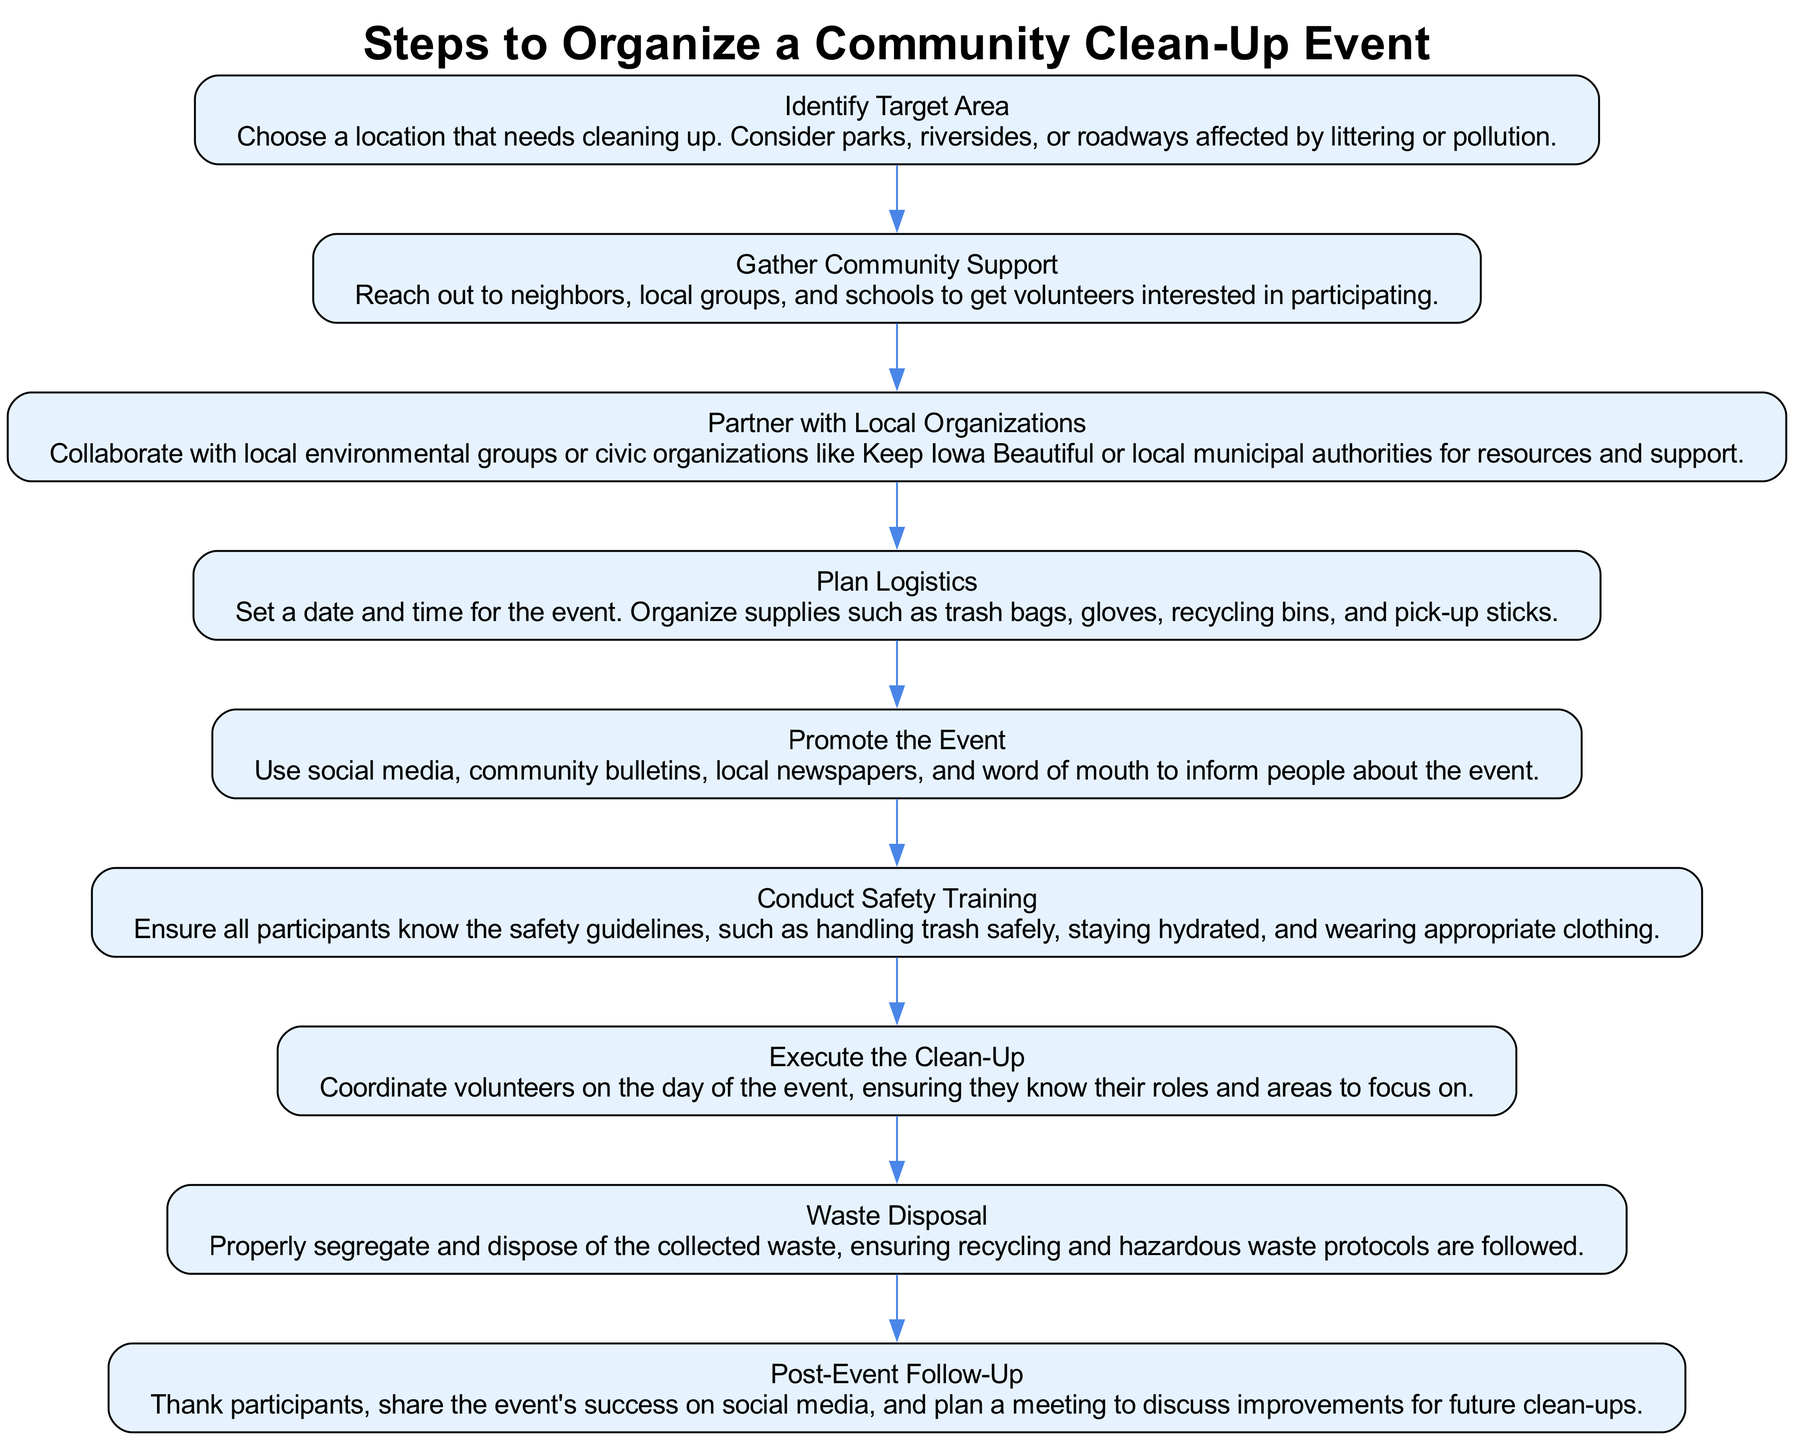What is the first step in organizing a community clean-up event? The diagram begins with the first node labeled "Identify Target Area," which indicates that this is the starting point of the process.
Answer: Identify Target Area How many steps are there in total? By counting the number of nodes listed in the diagram, there are nine distinct steps that outline the organization of the event.
Answer: Nine What should be done after gathering community support? The diagram shows that after "Gather Community Support," the next action is to "Partner with Local Organizations," indicating the progression of steps.
Answer: Partner with Local Organizations What is the last step in the clean-up process? The final step on the diagram is labeled "Post-Event Follow-Up," which signifies the conclusive action to be taken after executing the clean-up.
Answer: Post-Event Follow-Up What resources are needed during the logistics planning phase? Within the "Plan Logistics" step, the diagram specifies organizing supplies such as trash bags, gloves, recycling bins, and pick-up sticks as necessary resources.
Answer: Trash bags, gloves, recycling bins, pick-up sticks What kind of support should be pursued after identifying the target area? The connection in the flow chart indicates that after identifying the target area, the following necessary support involves gathering community volunteers to participate.
Answer: Community Support In what step will safety training be conducted? The diagram shows that safety training is specifically addressed in the step titled "Conduct Safety Training," which clarifies when this training occurs.
Answer: Conduct Safety Training What actions need to be taken for waste disposal? The "Waste Disposal" step in the diagram requires proper segregation and disposal of the collected waste while ensuring that recycling and hazardous waste protocols are adhered to.
Answer: Properly segregate and dispose of waste 